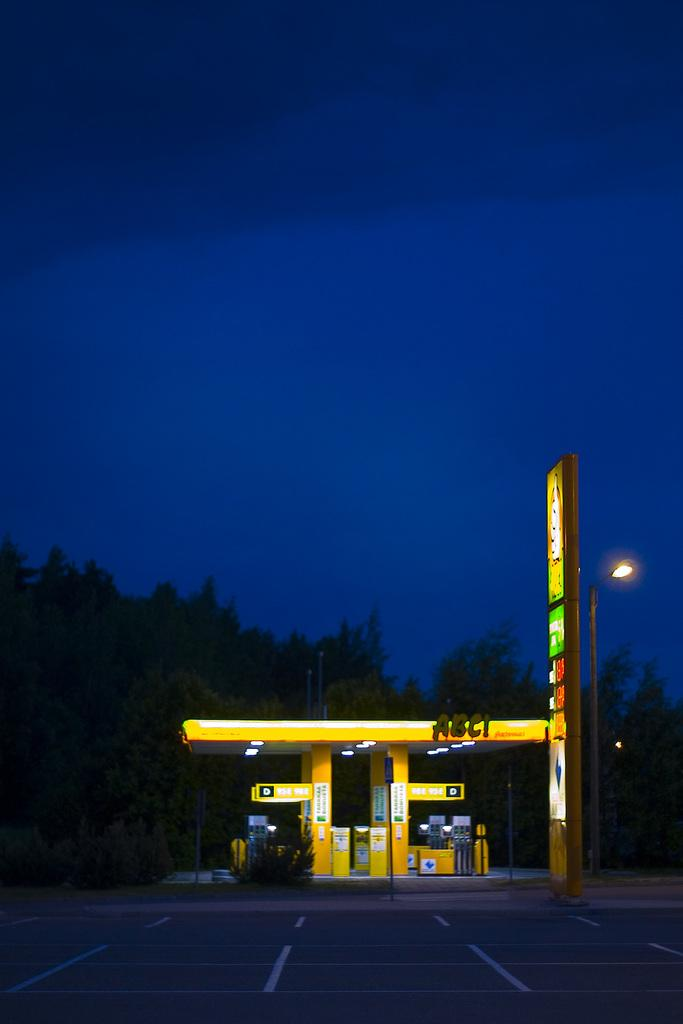<image>
Present a compact description of the photo's key features. The letters ABC! are on the roof of this pod of gas pumps. 